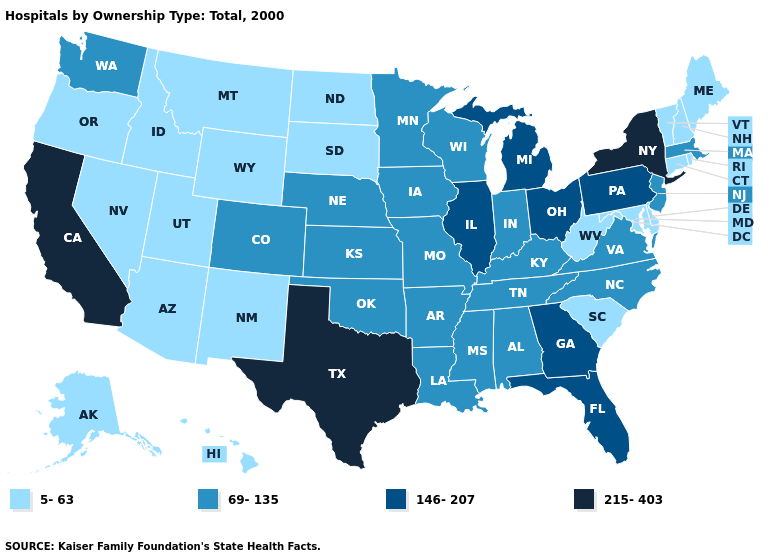Name the states that have a value in the range 146-207?
Write a very short answer. Florida, Georgia, Illinois, Michigan, Ohio, Pennsylvania. Name the states that have a value in the range 69-135?
Short answer required. Alabama, Arkansas, Colorado, Indiana, Iowa, Kansas, Kentucky, Louisiana, Massachusetts, Minnesota, Mississippi, Missouri, Nebraska, New Jersey, North Carolina, Oklahoma, Tennessee, Virginia, Washington, Wisconsin. Does the map have missing data?
Keep it brief. No. Name the states that have a value in the range 146-207?
Keep it brief. Florida, Georgia, Illinois, Michigan, Ohio, Pennsylvania. Among the states that border Illinois , which have the lowest value?
Give a very brief answer. Indiana, Iowa, Kentucky, Missouri, Wisconsin. Does Minnesota have a higher value than Rhode Island?
Be succinct. Yes. Does North Dakota have the lowest value in the USA?
Quick response, please. Yes. Which states hav the highest value in the Northeast?
Give a very brief answer. New York. What is the value of Florida?
Quick response, please. 146-207. What is the value of Iowa?
Short answer required. 69-135. Name the states that have a value in the range 69-135?
Answer briefly. Alabama, Arkansas, Colorado, Indiana, Iowa, Kansas, Kentucky, Louisiana, Massachusetts, Minnesota, Mississippi, Missouri, Nebraska, New Jersey, North Carolina, Oklahoma, Tennessee, Virginia, Washington, Wisconsin. What is the value of Utah?
Answer briefly. 5-63. What is the lowest value in the USA?
Keep it brief. 5-63. Which states have the highest value in the USA?
Write a very short answer. California, New York, Texas. Does New Hampshire have a higher value than Kentucky?
Keep it brief. No. 